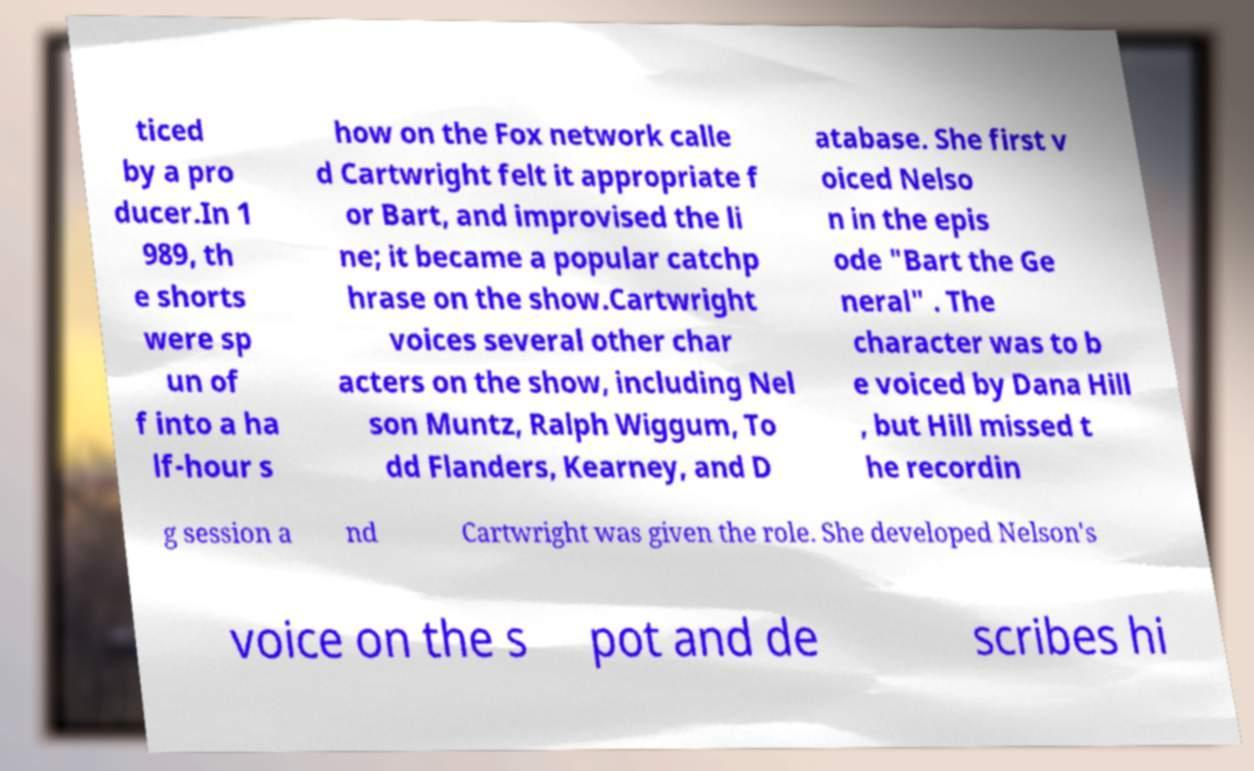Could you extract and type out the text from this image? ticed by a pro ducer.In 1 989, th e shorts were sp un of f into a ha lf-hour s how on the Fox network calle d Cartwright felt it appropriate f or Bart, and improvised the li ne; it became a popular catchp hrase on the show.Cartwright voices several other char acters on the show, including Nel son Muntz, Ralph Wiggum, To dd Flanders, Kearney, and D atabase. She first v oiced Nelso n in the epis ode "Bart the Ge neral" . The character was to b e voiced by Dana Hill , but Hill missed t he recordin g session a nd Cartwright was given the role. She developed Nelson's voice on the s pot and de scribes hi 